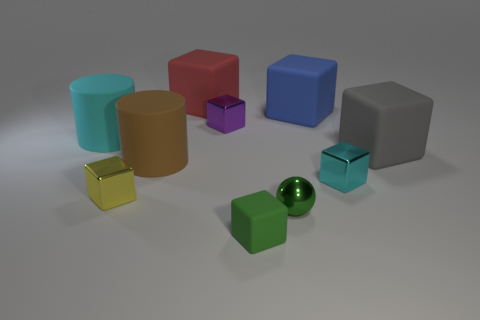There is a rubber thing that is the same color as the tiny ball; what is its shape?
Ensure brevity in your answer.  Cube. Does the small yellow metallic object have the same shape as the big rubber thing to the right of the blue rubber block?
Offer a very short reply. Yes. There is a cyan thing that is right of the purple metal cube; is its shape the same as the gray matte thing?
Offer a terse response. Yes. Are there more purple things than yellow metal balls?
Give a very brief answer. Yes. Is there a cyan object that has the same size as the green block?
Ensure brevity in your answer.  Yes. What number of objects are either small things that are on the right side of the big red matte cube or large gray rubber objects in front of the blue rubber thing?
Keep it short and to the point. 5. The tiny object behind the tiny metallic block that is to the right of the blue rubber object is what color?
Keep it short and to the point. Purple. What color is the sphere that is made of the same material as the small purple cube?
Provide a short and direct response. Green. What number of tiny cubes are the same color as the small matte thing?
Your response must be concise. 0. What number of things are yellow cubes or large brown rubber objects?
Your answer should be compact. 2. 